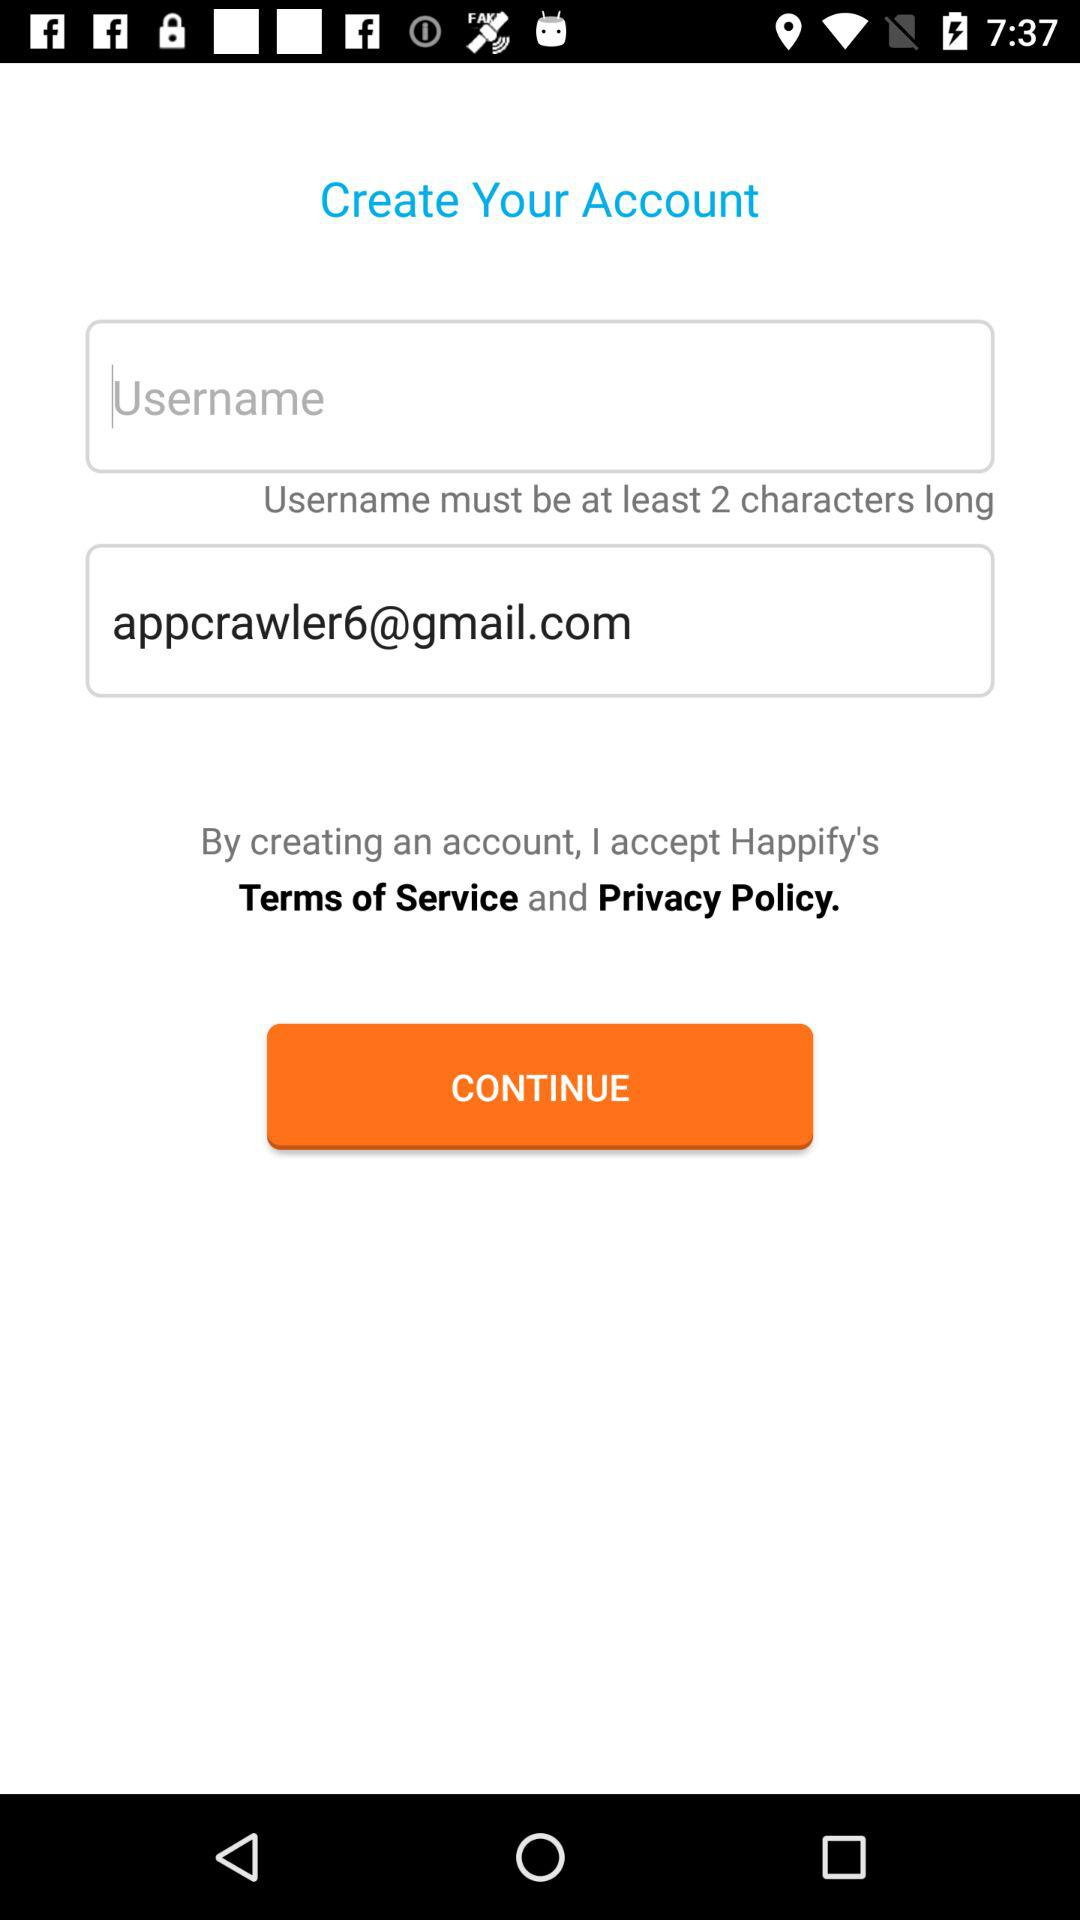How many characters can be in a username? There can be at least 2 characters in a username. 